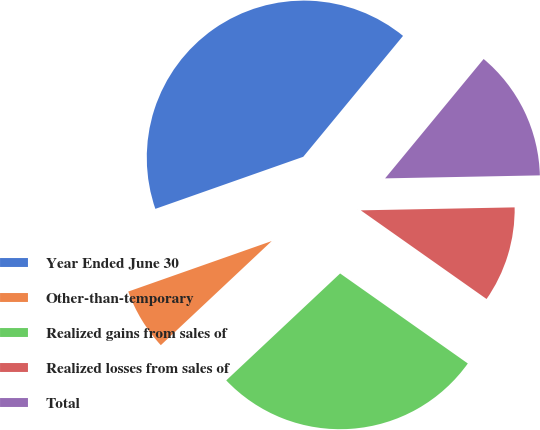Convert chart to OTSL. <chart><loc_0><loc_0><loc_500><loc_500><pie_chart><fcel>Year Ended June 30<fcel>Other-than-temporary<fcel>Realized gains from sales of<fcel>Realized losses from sales of<fcel>Total<nl><fcel>41.37%<fcel>6.61%<fcel>28.23%<fcel>10.08%<fcel>13.71%<nl></chart> 